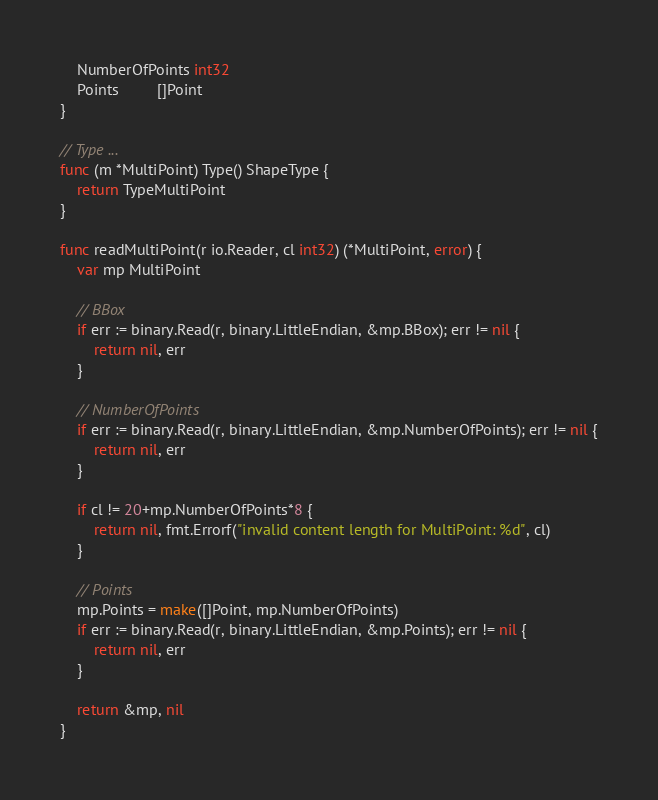Convert code to text. <code><loc_0><loc_0><loc_500><loc_500><_Go_>	NumberOfPoints int32
	Points         []Point
}

// Type ...
func (m *MultiPoint) Type() ShapeType {
	return TypeMultiPoint
}

func readMultiPoint(r io.Reader, cl int32) (*MultiPoint, error) {
	var mp MultiPoint

	// BBox
	if err := binary.Read(r, binary.LittleEndian, &mp.BBox); err != nil {
		return nil, err
	}

	// NumberOfPoints
	if err := binary.Read(r, binary.LittleEndian, &mp.NumberOfPoints); err != nil {
		return nil, err
	}

	if cl != 20+mp.NumberOfPoints*8 {
		return nil, fmt.Errorf("invalid content length for MultiPoint: %d", cl)
	}

	// Points
	mp.Points = make([]Point, mp.NumberOfPoints)
	if err := binary.Read(r, binary.LittleEndian, &mp.Points); err != nil {
		return nil, err
	}

	return &mp, nil
}
</code> 